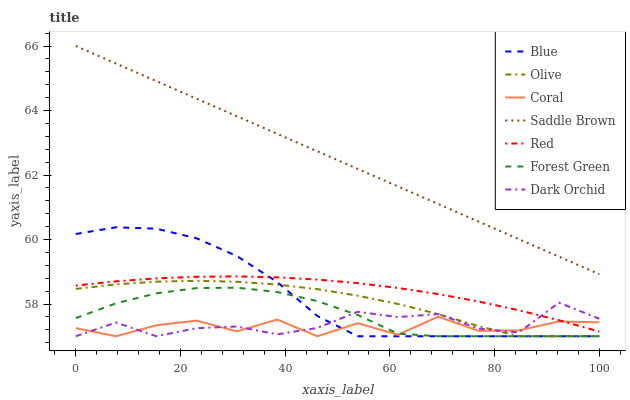Does Coral have the minimum area under the curve?
Answer yes or no. Yes. Does Saddle Brown have the maximum area under the curve?
Answer yes or no. Yes. Does Dark Orchid have the minimum area under the curve?
Answer yes or no. No. Does Dark Orchid have the maximum area under the curve?
Answer yes or no. No. Is Saddle Brown the smoothest?
Answer yes or no. Yes. Is Coral the roughest?
Answer yes or no. Yes. Is Dark Orchid the smoothest?
Answer yes or no. No. Is Dark Orchid the roughest?
Answer yes or no. No. Does Blue have the lowest value?
Answer yes or no. Yes. Does Saddle Brown have the lowest value?
Answer yes or no. No. Does Saddle Brown have the highest value?
Answer yes or no. Yes. Does Dark Orchid have the highest value?
Answer yes or no. No. Is Red less than Saddle Brown?
Answer yes or no. Yes. Is Saddle Brown greater than Dark Orchid?
Answer yes or no. Yes. Does Forest Green intersect Dark Orchid?
Answer yes or no. Yes. Is Forest Green less than Dark Orchid?
Answer yes or no. No. Is Forest Green greater than Dark Orchid?
Answer yes or no. No. Does Red intersect Saddle Brown?
Answer yes or no. No. 